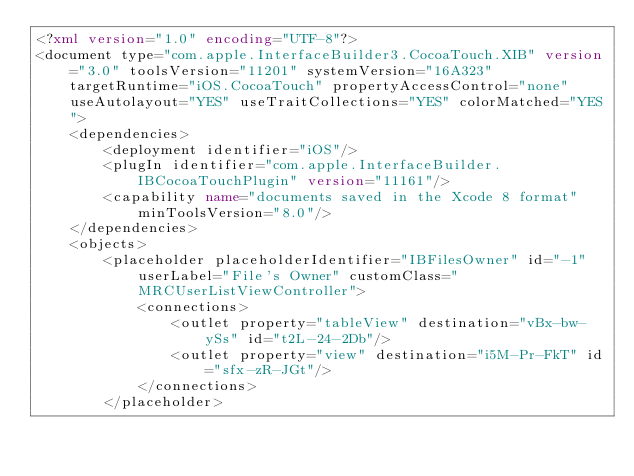Convert code to text. <code><loc_0><loc_0><loc_500><loc_500><_XML_><?xml version="1.0" encoding="UTF-8"?>
<document type="com.apple.InterfaceBuilder3.CocoaTouch.XIB" version="3.0" toolsVersion="11201" systemVersion="16A323" targetRuntime="iOS.CocoaTouch" propertyAccessControl="none" useAutolayout="YES" useTraitCollections="YES" colorMatched="YES">
    <dependencies>
        <deployment identifier="iOS"/>
        <plugIn identifier="com.apple.InterfaceBuilder.IBCocoaTouchPlugin" version="11161"/>
        <capability name="documents saved in the Xcode 8 format" minToolsVersion="8.0"/>
    </dependencies>
    <objects>
        <placeholder placeholderIdentifier="IBFilesOwner" id="-1" userLabel="File's Owner" customClass="MRCUserListViewController">
            <connections>
                <outlet property="tableView" destination="vBx-bw-ySs" id="t2L-24-2Db"/>
                <outlet property="view" destination="i5M-Pr-FkT" id="sfx-zR-JGt"/>
            </connections>
        </placeholder></code> 